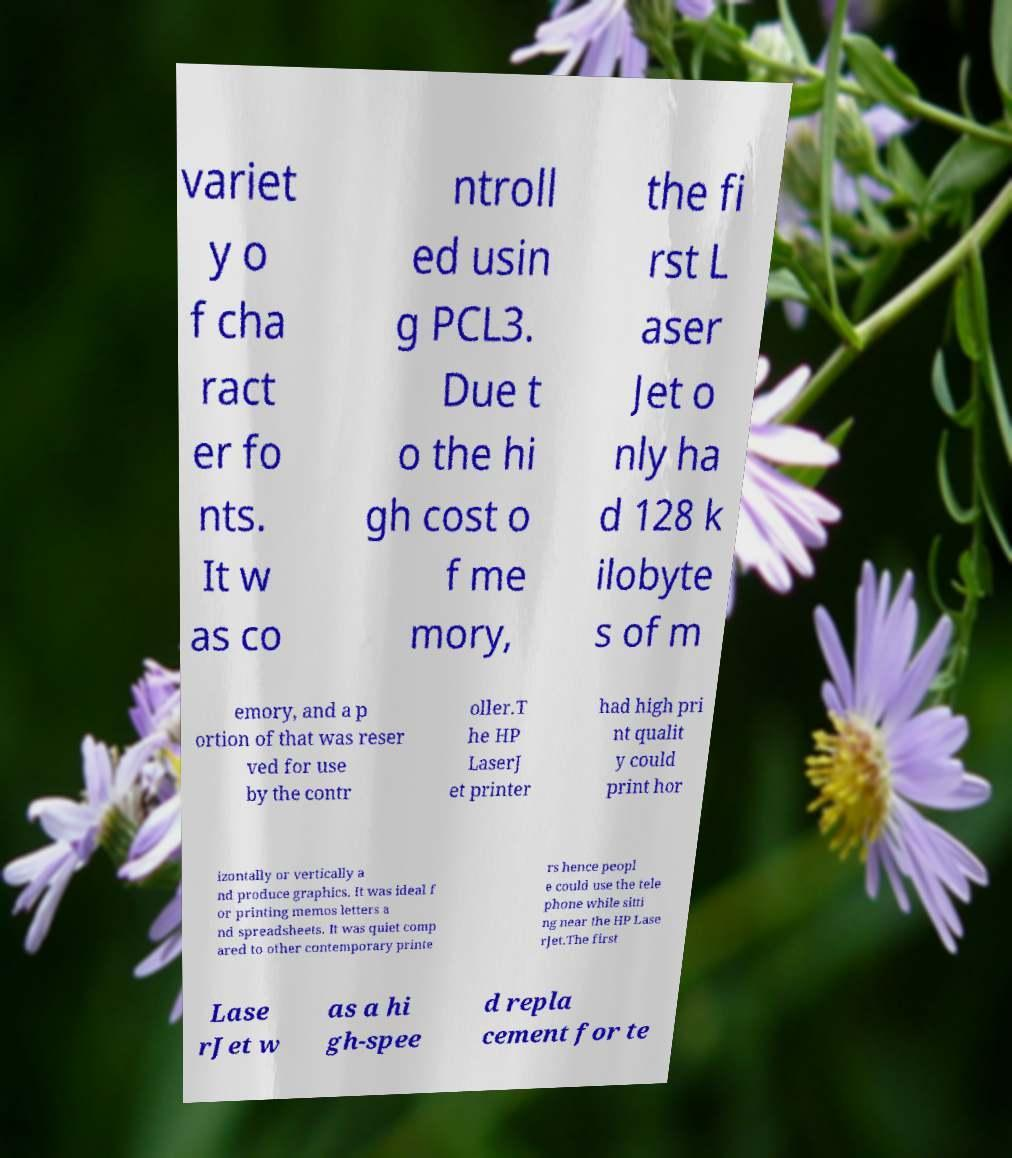Could you assist in decoding the text presented in this image and type it out clearly? variet y o f cha ract er fo nts. It w as co ntroll ed usin g PCL3. Due t o the hi gh cost o f me mory, the fi rst L aser Jet o nly ha d 128 k ilobyte s of m emory, and a p ortion of that was reser ved for use by the contr oller.T he HP LaserJ et printer had high pri nt qualit y could print hor izontally or vertically a nd produce graphics. It was ideal f or printing memos letters a nd spreadsheets. It was quiet comp ared to other contemporary printe rs hence peopl e could use the tele phone while sitti ng near the HP Lase rJet.The first Lase rJet w as a hi gh-spee d repla cement for te 